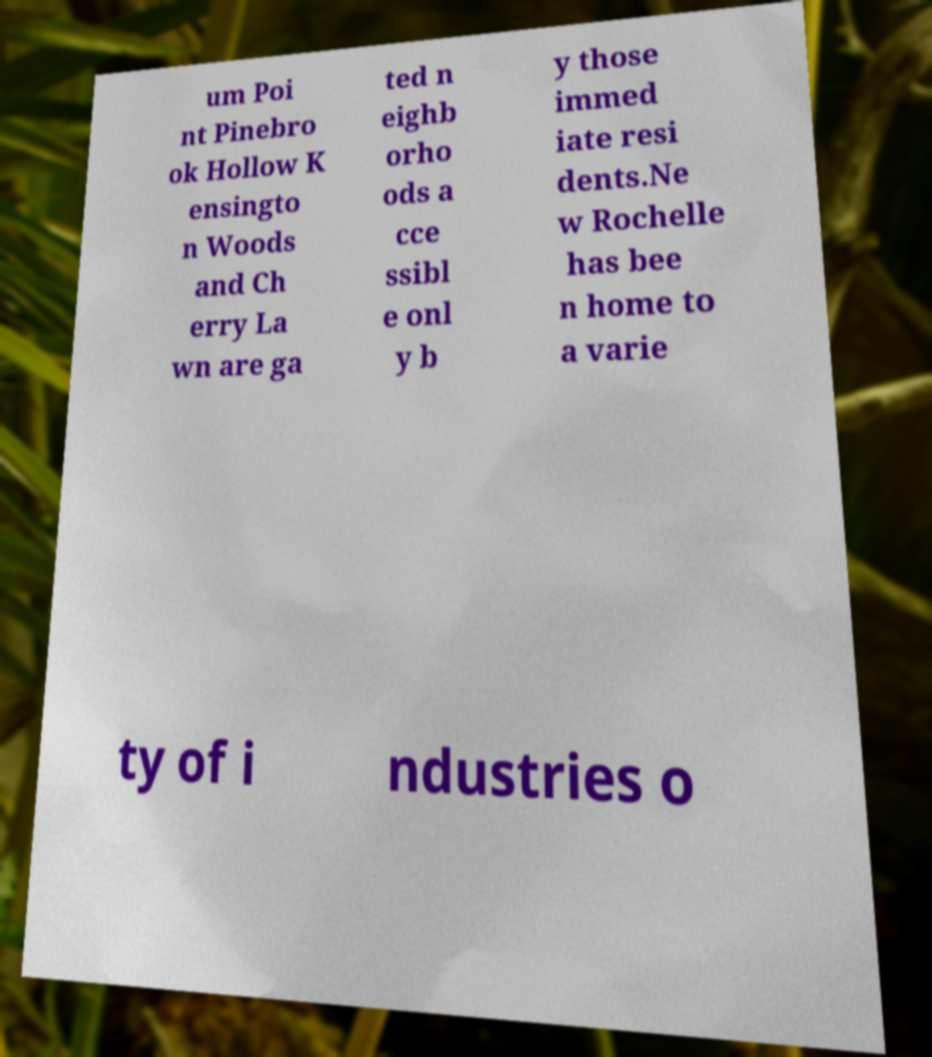What messages or text are displayed in this image? I need them in a readable, typed format. um Poi nt Pinebro ok Hollow K ensingto n Woods and Ch erry La wn are ga ted n eighb orho ods a cce ssibl e onl y b y those immed iate resi dents.Ne w Rochelle has bee n home to a varie ty of i ndustries o 